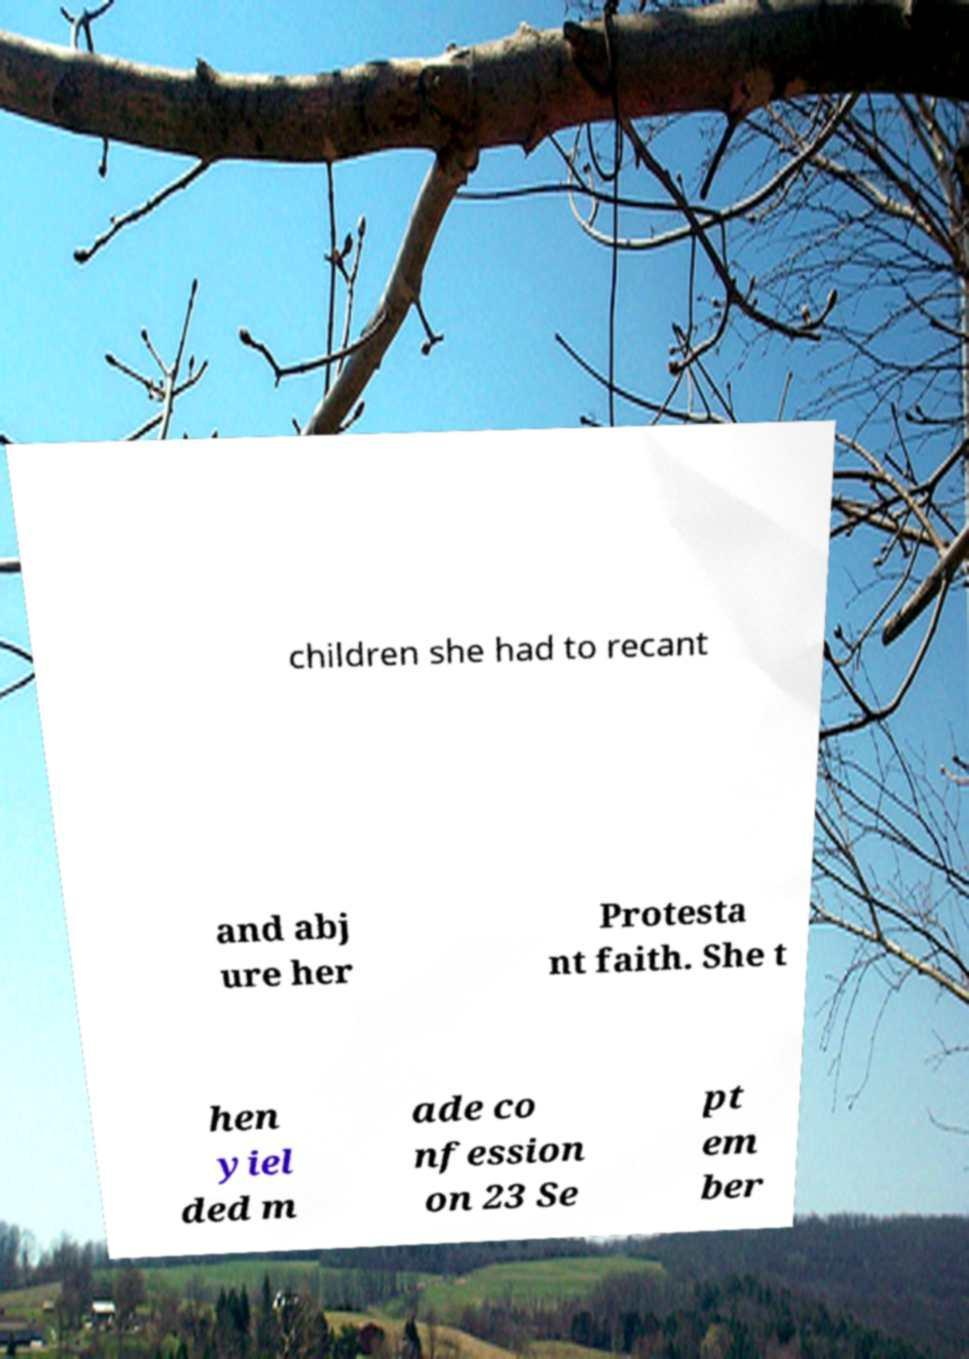Can you accurately transcribe the text from the provided image for me? children she had to recant and abj ure her Protesta nt faith. She t hen yiel ded m ade co nfession on 23 Se pt em ber 